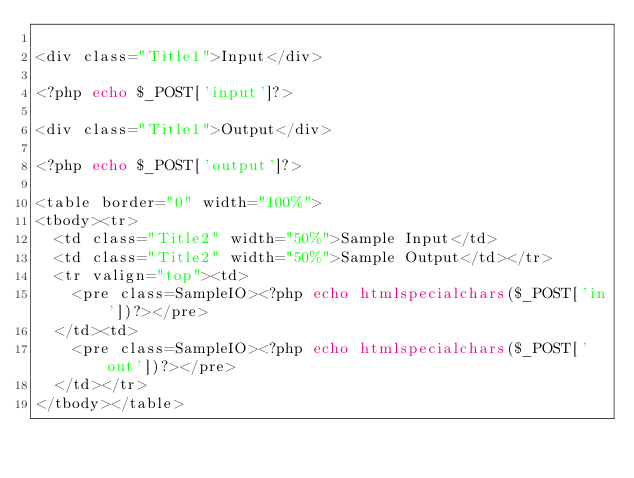<code> <loc_0><loc_0><loc_500><loc_500><_PHP_>
<div class="Title1">Input</div>

<?php echo $_POST['input']?>

<div class="Title1">Output</div>

<?php echo $_POST['output']?>

<table border="0" width="100%">
<tbody><tr>
  <td class="Title2" width="50%">Sample Input</td>
  <td class="Title2" width="50%">Sample Output</td></tr>
  <tr valign="top"><td>
    <pre class=SampleIO><?php echo htmlspecialchars($_POST['in'])?></pre>
  </td><td>
    <pre class=SampleIO><?php echo htmlspecialchars($_POST['out'])?></pre>
  </td></tr>
</tbody></table>
</code> 